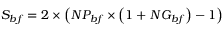<formula> <loc_0><loc_0><loc_500><loc_500>S _ { b f } = 2 \times \left ( N P _ { b f } \times \left ( 1 + N G _ { b f } \right ) - 1 \right )</formula> 